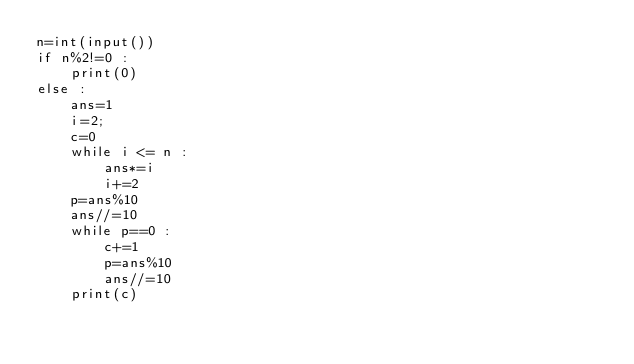Convert code to text. <code><loc_0><loc_0><loc_500><loc_500><_Python_>n=int(input())
if n%2!=0 :
    print(0)
else :
    ans=1
    i=2;
    c=0
    while i <= n :
        ans*=i
        i+=2
    p=ans%10
    ans//=10
    while p==0 :
        c+=1
        p=ans%10
        ans//=10
    print(c)</code> 